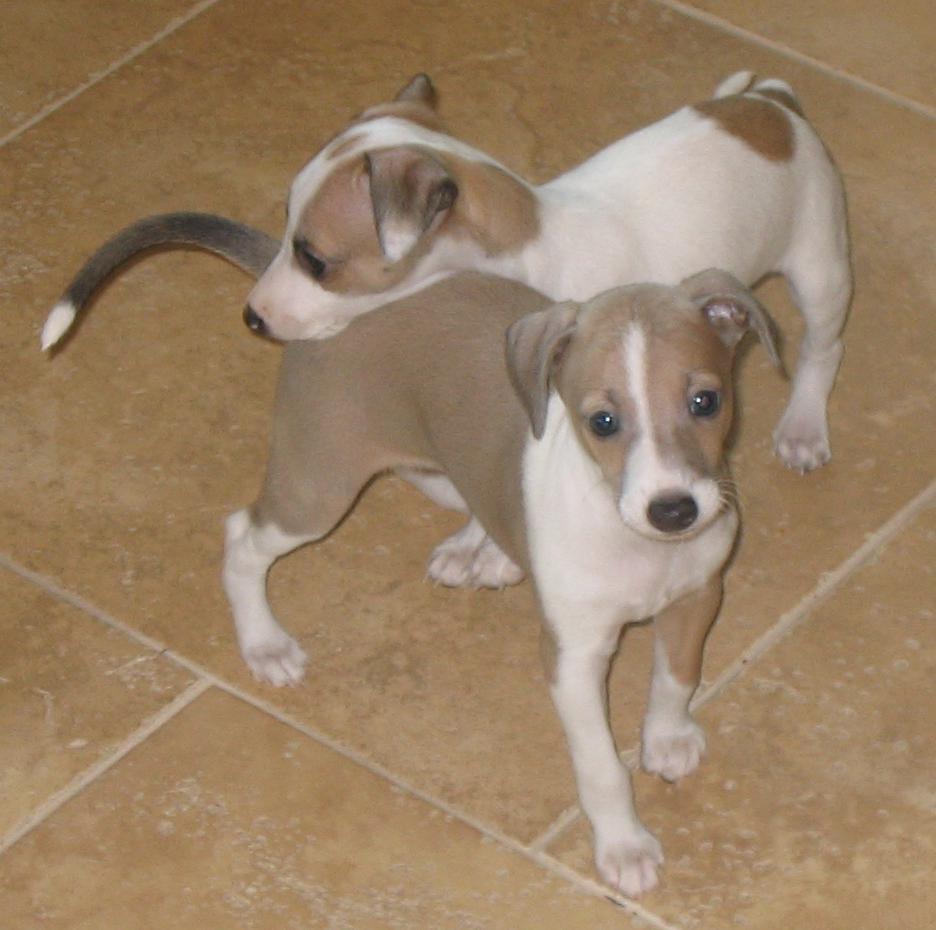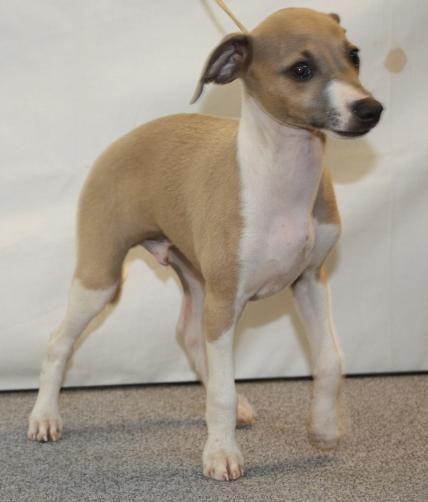The first image is the image on the left, the second image is the image on the right. Examine the images to the left and right. Is the description "Each image shows exactly one non-standing hound, and the combined images show at least one hound reclining with front paws extended in front of its body." accurate? Answer yes or no. No. The first image is the image on the left, the second image is the image on the right. Given the left and right images, does the statement "In one of the images the dog is on a tile floor." hold true? Answer yes or no. Yes. 